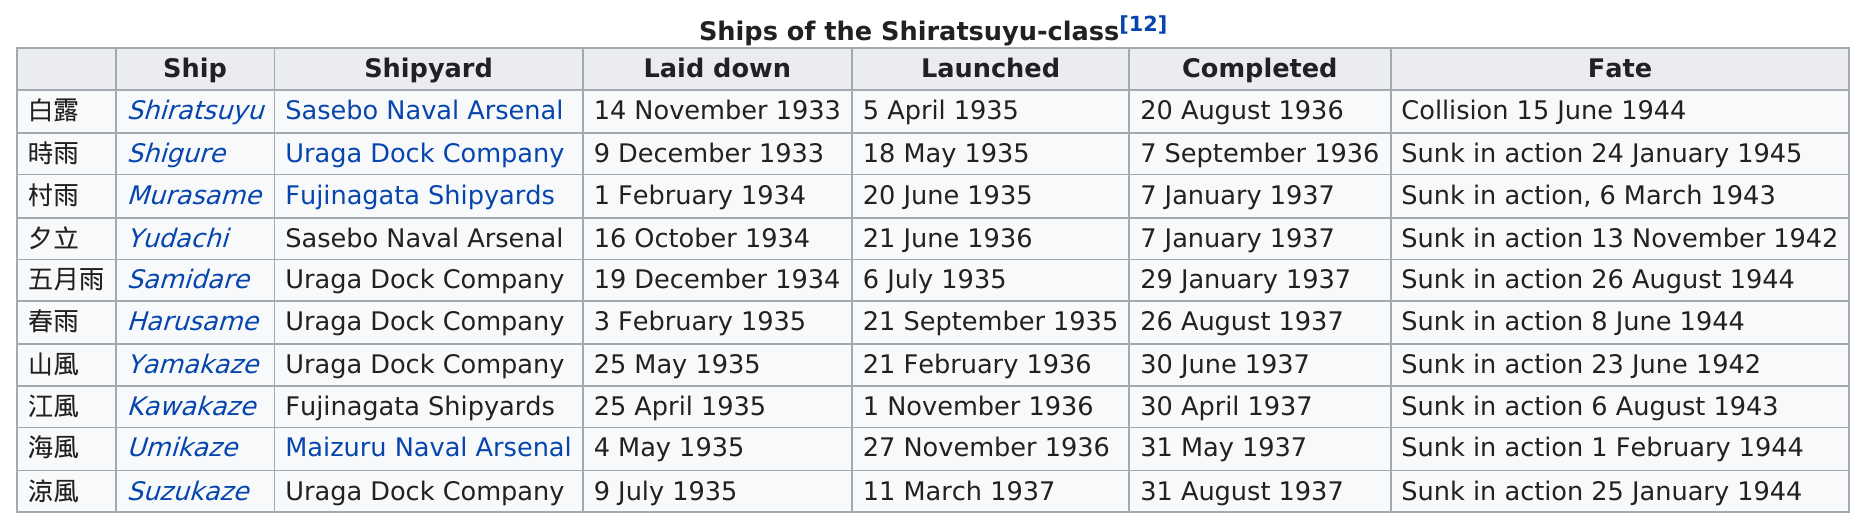Give some essential details in this illustration. The name of the only ship that did not sink was Shiratsuyu. On November 14th, 1933, Shiratsuyu left. The Uraga Dock Company was the shipyard that was used the most. All of the Shiratsuyu-class ships sank in 1944, with a total of 4 of them succumbing to the harsh conditions of the war. On November 13, 1942, the Japanese warship Yudachi was sunk, and it shared the same fate that year with the Yamakaze. 